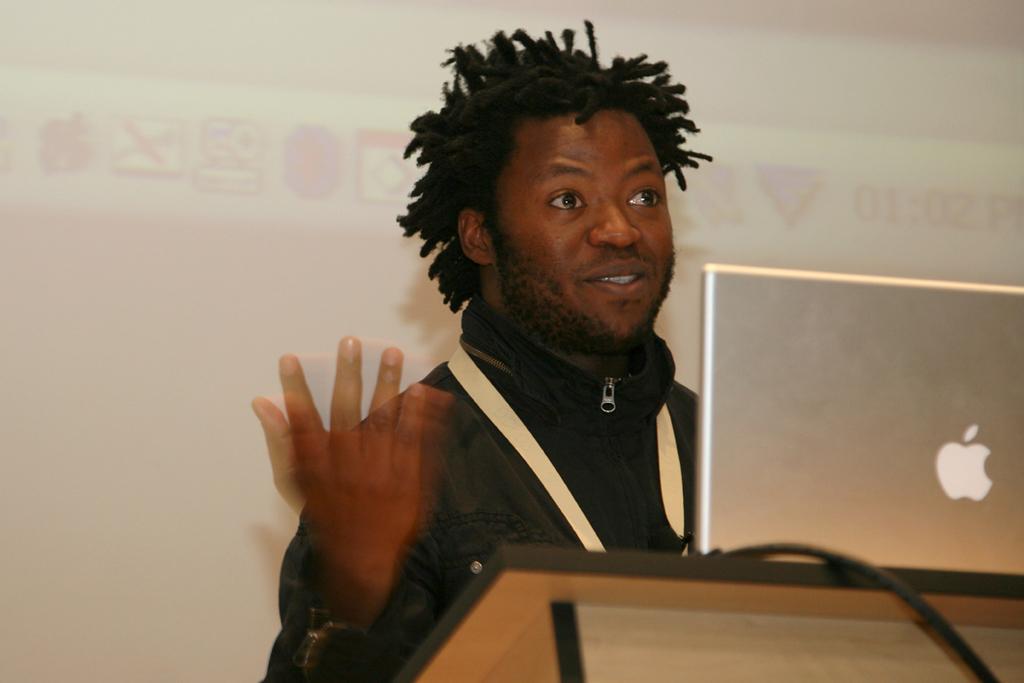Describe this image in one or two sentences. In this image there is a person standing behind the podium, on that podium there is a laptop, in the background it is white. 